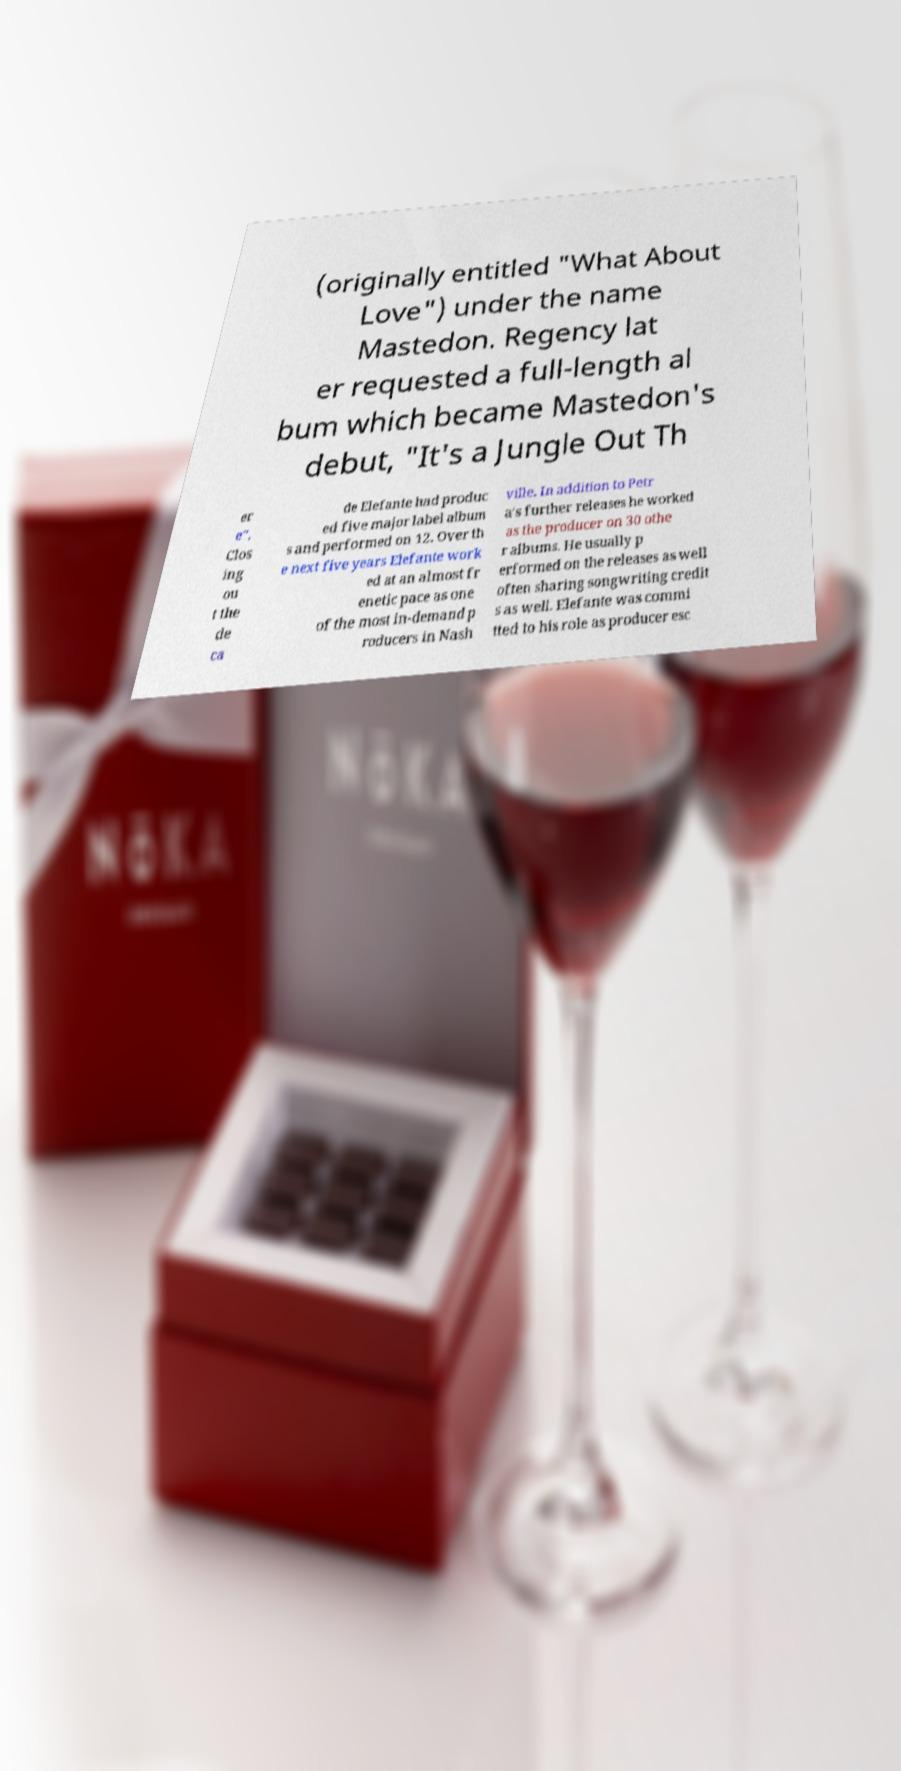Can you accurately transcribe the text from the provided image for me? (originally entitled "What About Love") under the name Mastedon. Regency lat er requested a full-length al bum which became Mastedon's debut, "It's a Jungle Out Th er e". Clos ing ou t the de ca de Elefante had produc ed five major label album s and performed on 12. Over th e next five years Elefante work ed at an almost fr enetic pace as one of the most in-demand p roducers in Nash ville. In addition to Petr a's further releases he worked as the producer on 30 othe r albums. He usually p erformed on the releases as well often sharing songwriting credit s as well. Elefante was commi tted to his role as producer esc 